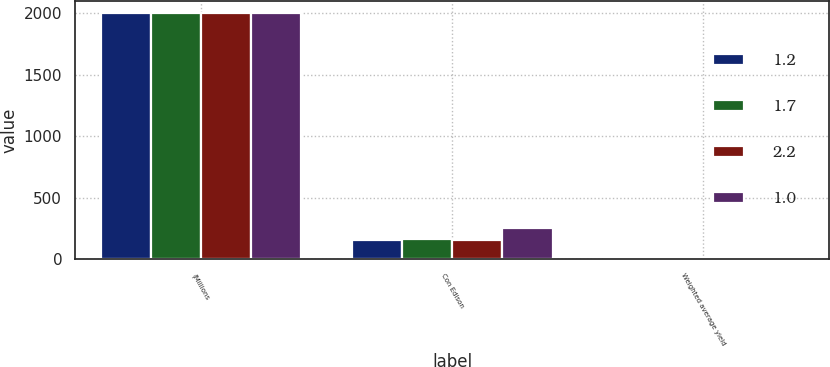Convert chart to OTSL. <chart><loc_0><loc_0><loc_500><loc_500><stacked_bar_chart><ecel><fcel>(Millions<fcel>Con Edison<fcel>Weighted average yield<nl><fcel>1.2<fcel>2004<fcel>156<fcel>2.2<nl><fcel>1.7<fcel>2004<fcel>166<fcel>1.2<nl><fcel>2.2<fcel>2003<fcel>156<fcel>1<nl><fcel>1<fcel>2002<fcel>256<fcel>1.7<nl></chart> 